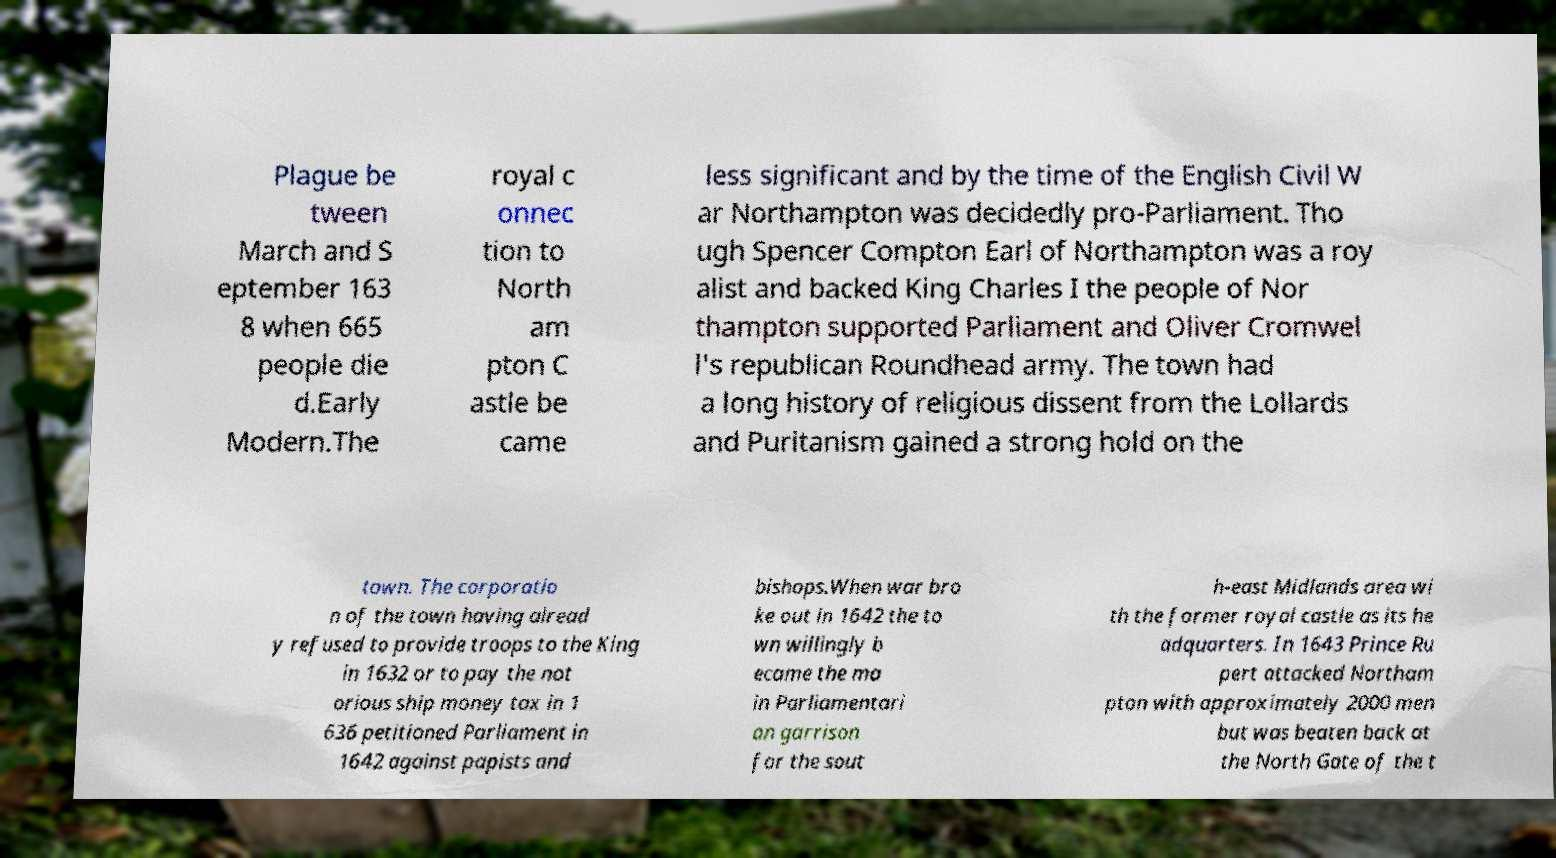For documentation purposes, I need the text within this image transcribed. Could you provide that? Plague be tween March and S eptember 163 8 when 665 people die d.Early Modern.The royal c onnec tion to North am pton C astle be came less significant and by the time of the English Civil W ar Northampton was decidedly pro-Parliament. Tho ugh Spencer Compton Earl of Northampton was a roy alist and backed King Charles I the people of Nor thampton supported Parliament and Oliver Cromwel l's republican Roundhead army. The town had a long history of religious dissent from the Lollards and Puritanism gained a strong hold on the town. The corporatio n of the town having alread y refused to provide troops to the King in 1632 or to pay the not orious ship money tax in 1 636 petitioned Parliament in 1642 against papists and bishops.When war bro ke out in 1642 the to wn willingly b ecame the ma in Parliamentari an garrison for the sout h-east Midlands area wi th the former royal castle as its he adquarters. In 1643 Prince Ru pert attacked Northam pton with approximately 2000 men but was beaten back at the North Gate of the t 